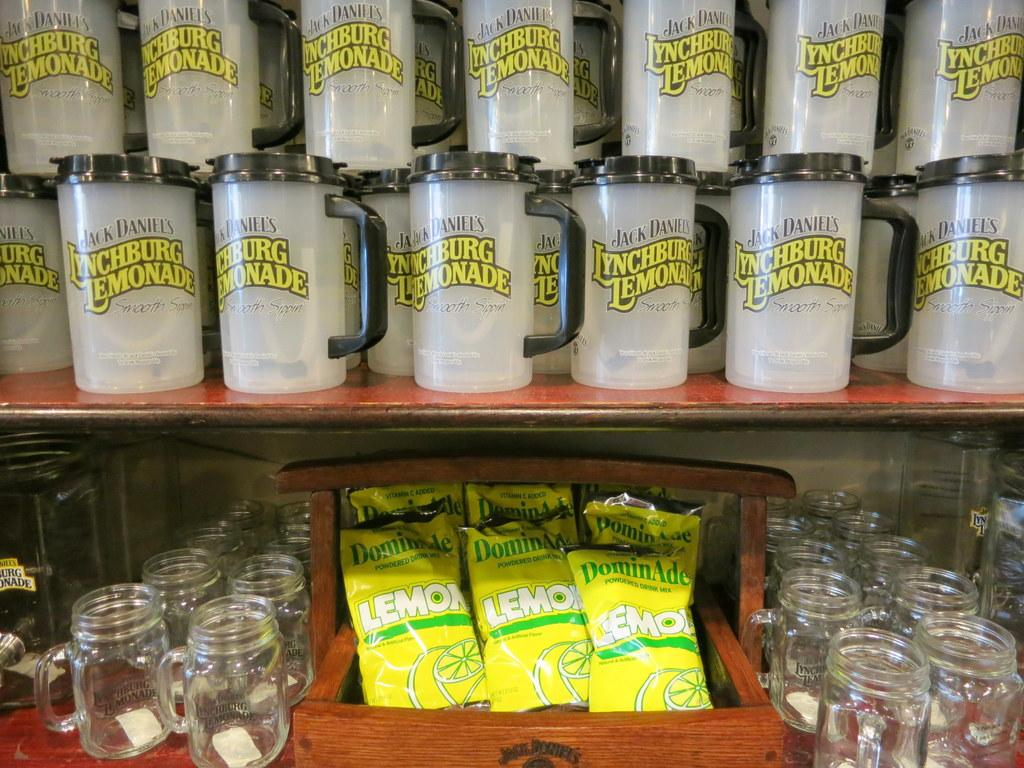<image>
Provide a brief description of the given image. A variety of merchandise bearing the Lynchburg lemonade brand is arranged in two rows with cups on top and glasses on the bottom. 